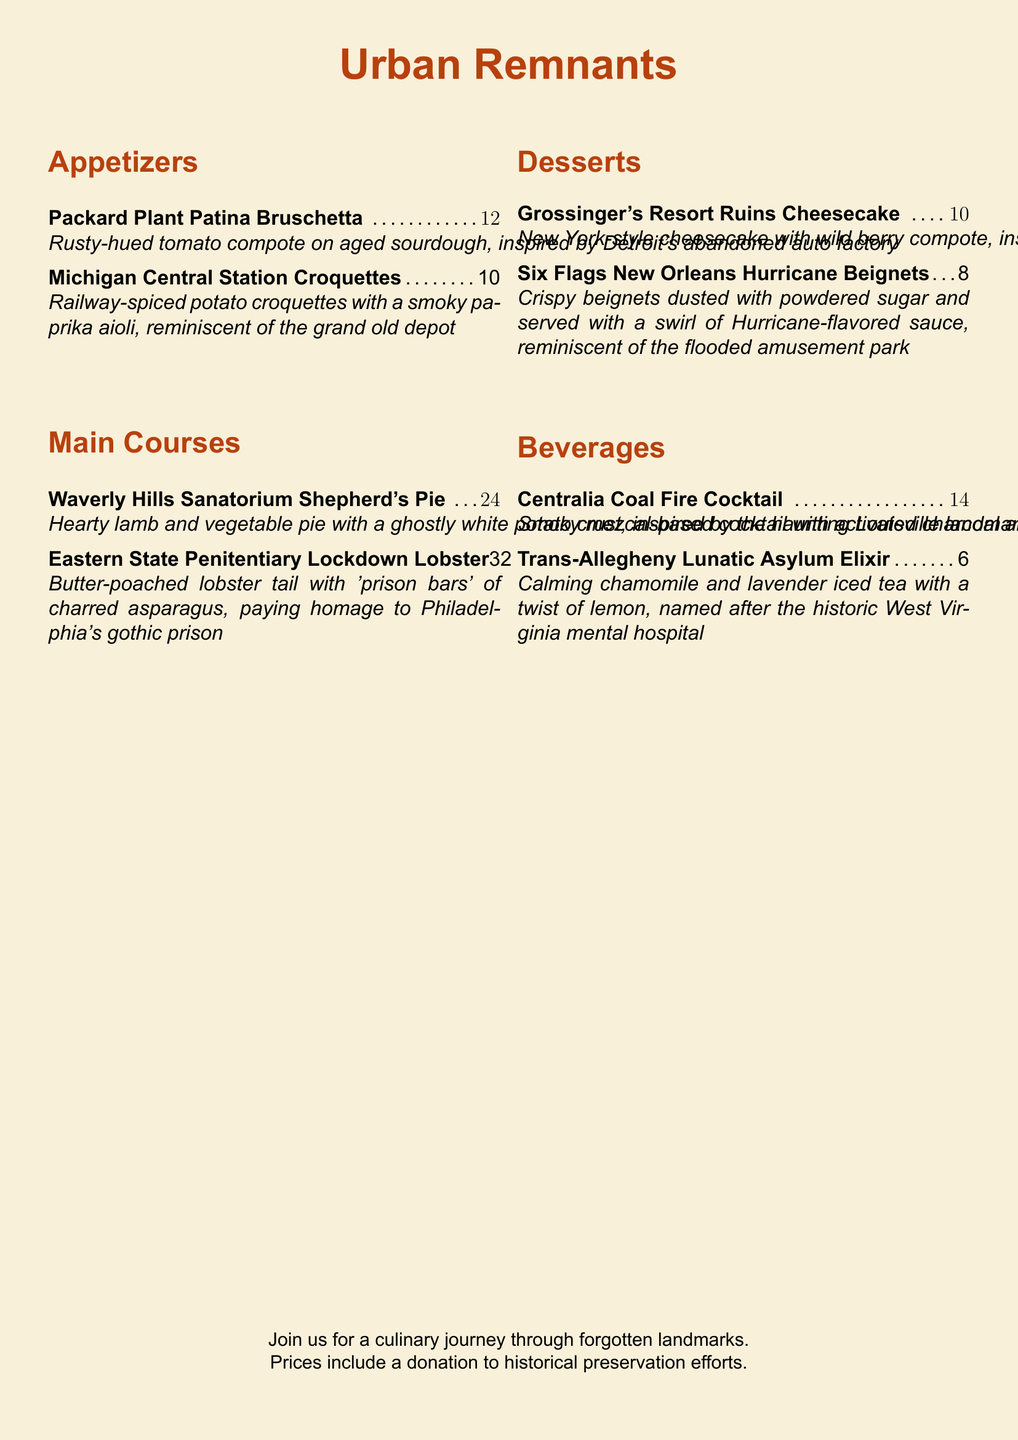What is the name of the dessert inspired by a Catskills resort? The dessert inspired by the Catskills resort is named "Grossinger's Resort Ruins Cheesecake."
Answer: Grossinger's Resort Ruins Cheesecake How much does the Waverly Hills Sanatorium Shepherd's Pie cost? The price of the Waverly Hills Sanatorium Shepherd's Pie is listed in the document.
Answer: $24 What is the main ingredient in the Centralia Coal Fire Cocktail? The main ingredient in the Centralia Coal Fire Cocktail is mezcal, as noted in the document.
Answer: mezcal Which appetizer features aged sourdough? The appetizer featuring aged sourdough is "Packard Plant Patina Bruschetta."
Answer: Packard Plant Patina Bruschetta How many appetizers are listed on the menu? The total number of appetizers can be counted from the section in the document.
Answer: 2 What inspired the Eastern State Penitentiary Lockdown Lobster? The Eastern State Penitentiary Lockdown Lobster is inspired by the "gothic prison" in Philadelphia.
Answer: Philadelphia's gothic prison What is served with the Six Flags New Orleans Hurricane Beignets? The document states that the Six Flags New Orleans Hurricane Beignets are served with "a swirl of Hurricane-flavored sauce."
Answer: a swirl of Hurricane-flavored sauce What type of tea is the Trans-Allegheny Lunatic Asylum Elixir? The type of tea mentioned for the Trans-Allegheny Lunatic Asylum Elixir is chamomile and lavender iced tea.
Answer: chamomile and lavender iced tea 